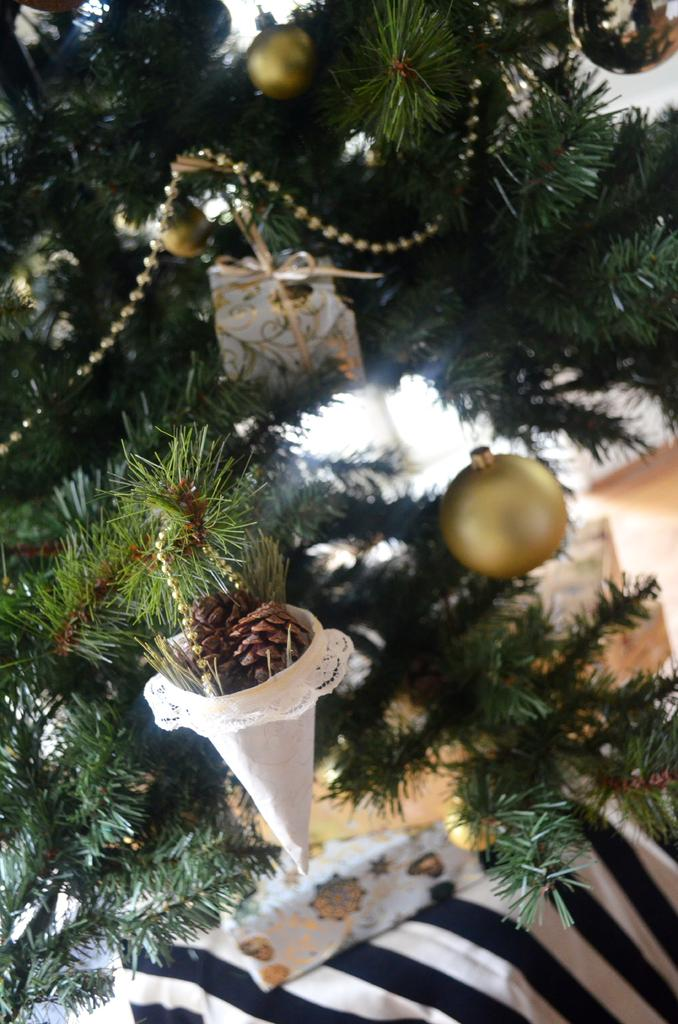What is the main subject of the picture? The main subject of the picture is a Christmas tree. What other items can be seen in the picture? There are bells, decorations, and gifts on the Christmas tree visible in the picture. What is the color of the cloth at the bottom of the image? The cloth at the bottom of the image is black and white. What type of wood can be seen in the picture? There is no wood visible in the picture; the main subject is a Christmas tree, which is typically made of an artificial material. How many letters are present in the picture? There is no mention of letters in the provided facts, so it cannot be determined how many letters are present in the picture. 